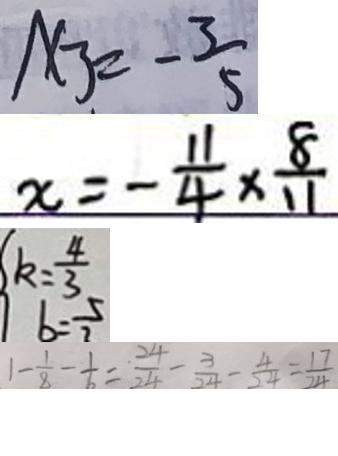<formula> <loc_0><loc_0><loc_500><loc_500>x _ { 3 } = - \frac { 3 } { 5 } 
 x = - \frac { 1 1 } { 4 } \times \frac { 8 } { 1 1 } 
 k = \frac { 4 } { 3 } 
 1 - \frac { 1 } { 8 } - \frac { 1 } { 6 } = \frac { 2 4 } { 2 4 } - \frac { 3 } { 2 4 } - \frac { 4 } { 2 4 } = \frac { 1 7 } { 2 4 }</formula> 